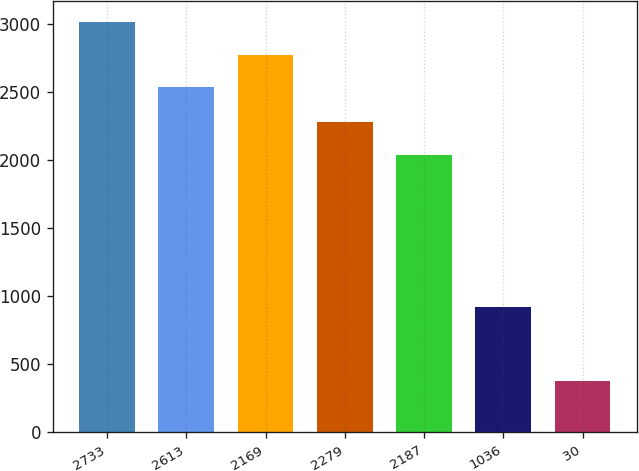Convert chart. <chart><loc_0><loc_0><loc_500><loc_500><bar_chart><fcel>2733<fcel>2613<fcel>2169<fcel>2279<fcel>2187<fcel>1036<fcel>30<nl><fcel>3019.2<fcel>2535<fcel>2777.1<fcel>2282.1<fcel>2040<fcel>920<fcel>378<nl></chart> 